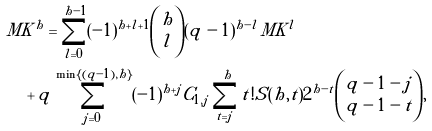Convert formula to latex. <formula><loc_0><loc_0><loc_500><loc_500>& M K ^ { h } = \sum _ { l = 0 } ^ { h - 1 } ( - 1 ) ^ { h + l + 1 } { \binom { h } { l } } ( q - 1 ) ^ { h - l } M K ^ { l } \\ & \quad + q \sum _ { j = 0 } ^ { \min \{ ( q - 1 ) , h \} } ( - 1 ) ^ { h + j } C _ { 1 , j } \sum _ { t = j } ^ { h } t ! S ( h , t ) 2 ^ { h - t } { \binom { { q - 1 } - j } { { q - 1 } - t } } ,</formula> 